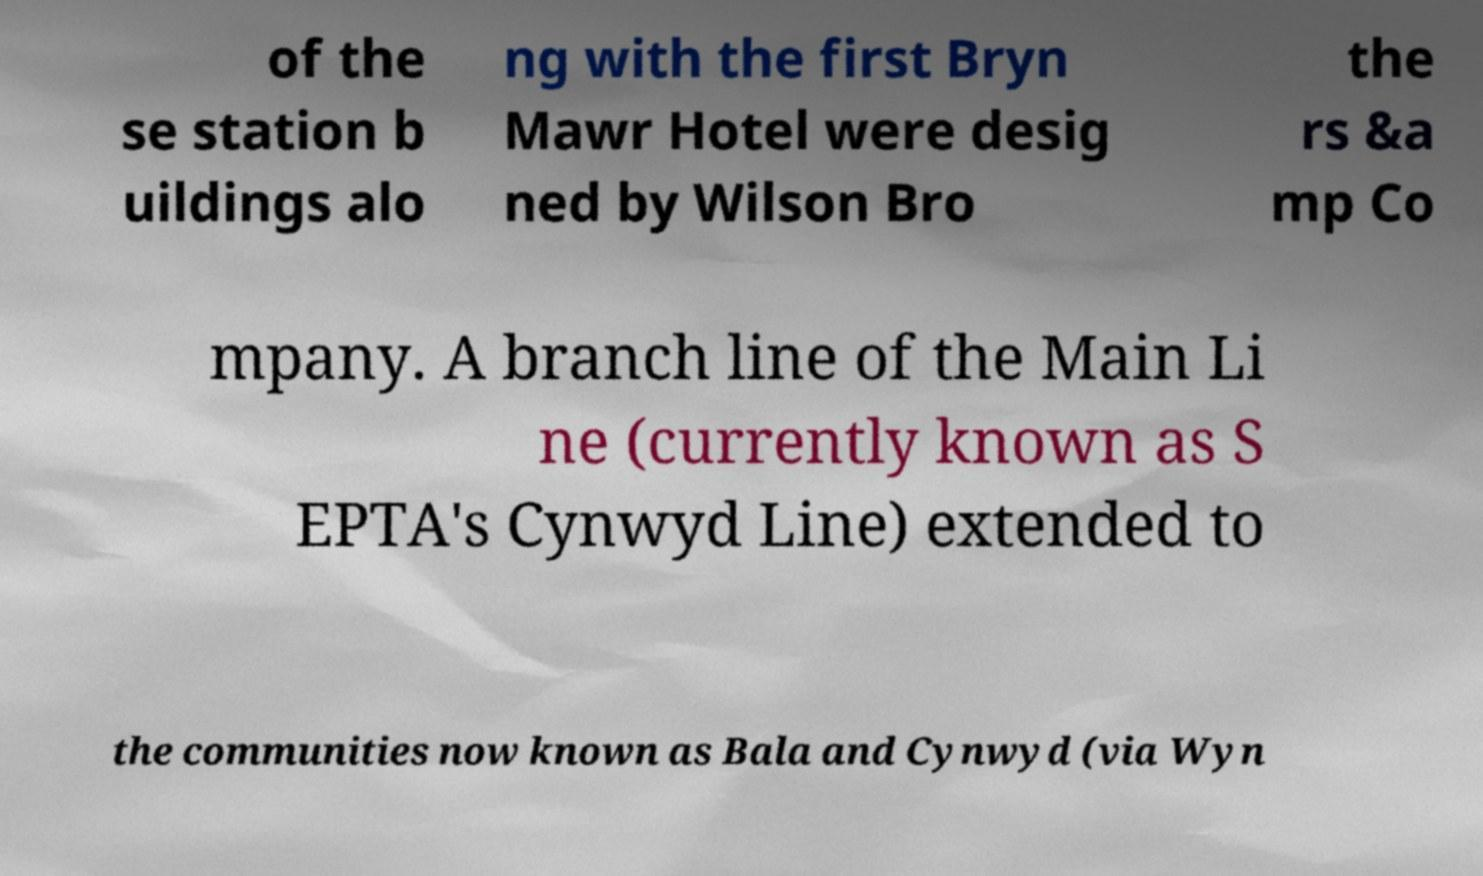Please read and relay the text visible in this image. What does it say? of the se station b uildings alo ng with the first Bryn Mawr Hotel were desig ned by Wilson Bro the rs &a mp Co mpany. A branch line of the Main Li ne (currently known as S EPTA's Cynwyd Line) extended to the communities now known as Bala and Cynwyd (via Wyn 